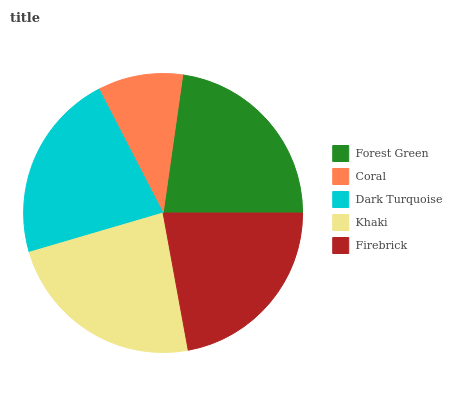Is Coral the minimum?
Answer yes or no. Yes. Is Khaki the maximum?
Answer yes or no. Yes. Is Dark Turquoise the minimum?
Answer yes or no. No. Is Dark Turquoise the maximum?
Answer yes or no. No. Is Dark Turquoise greater than Coral?
Answer yes or no. Yes. Is Coral less than Dark Turquoise?
Answer yes or no. Yes. Is Coral greater than Dark Turquoise?
Answer yes or no. No. Is Dark Turquoise less than Coral?
Answer yes or no. No. Is Firebrick the high median?
Answer yes or no. Yes. Is Firebrick the low median?
Answer yes or no. Yes. Is Forest Green the high median?
Answer yes or no. No. Is Coral the low median?
Answer yes or no. No. 